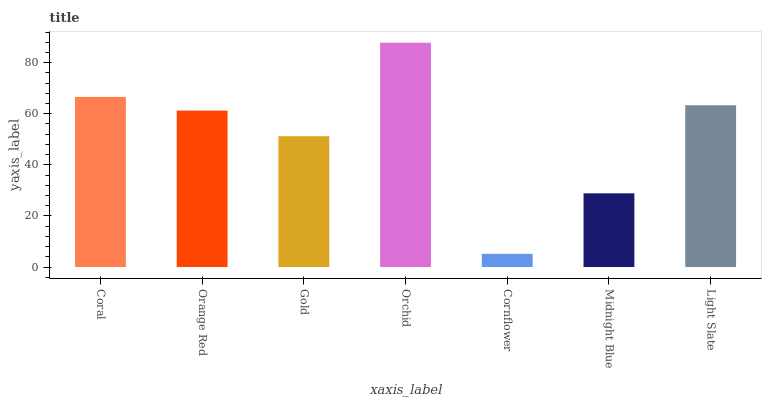Is Cornflower the minimum?
Answer yes or no. Yes. Is Orchid the maximum?
Answer yes or no. Yes. Is Orange Red the minimum?
Answer yes or no. No. Is Orange Red the maximum?
Answer yes or no. No. Is Coral greater than Orange Red?
Answer yes or no. Yes. Is Orange Red less than Coral?
Answer yes or no. Yes. Is Orange Red greater than Coral?
Answer yes or no. No. Is Coral less than Orange Red?
Answer yes or no. No. Is Orange Red the high median?
Answer yes or no. Yes. Is Orange Red the low median?
Answer yes or no. Yes. Is Orchid the high median?
Answer yes or no. No. Is Midnight Blue the low median?
Answer yes or no. No. 